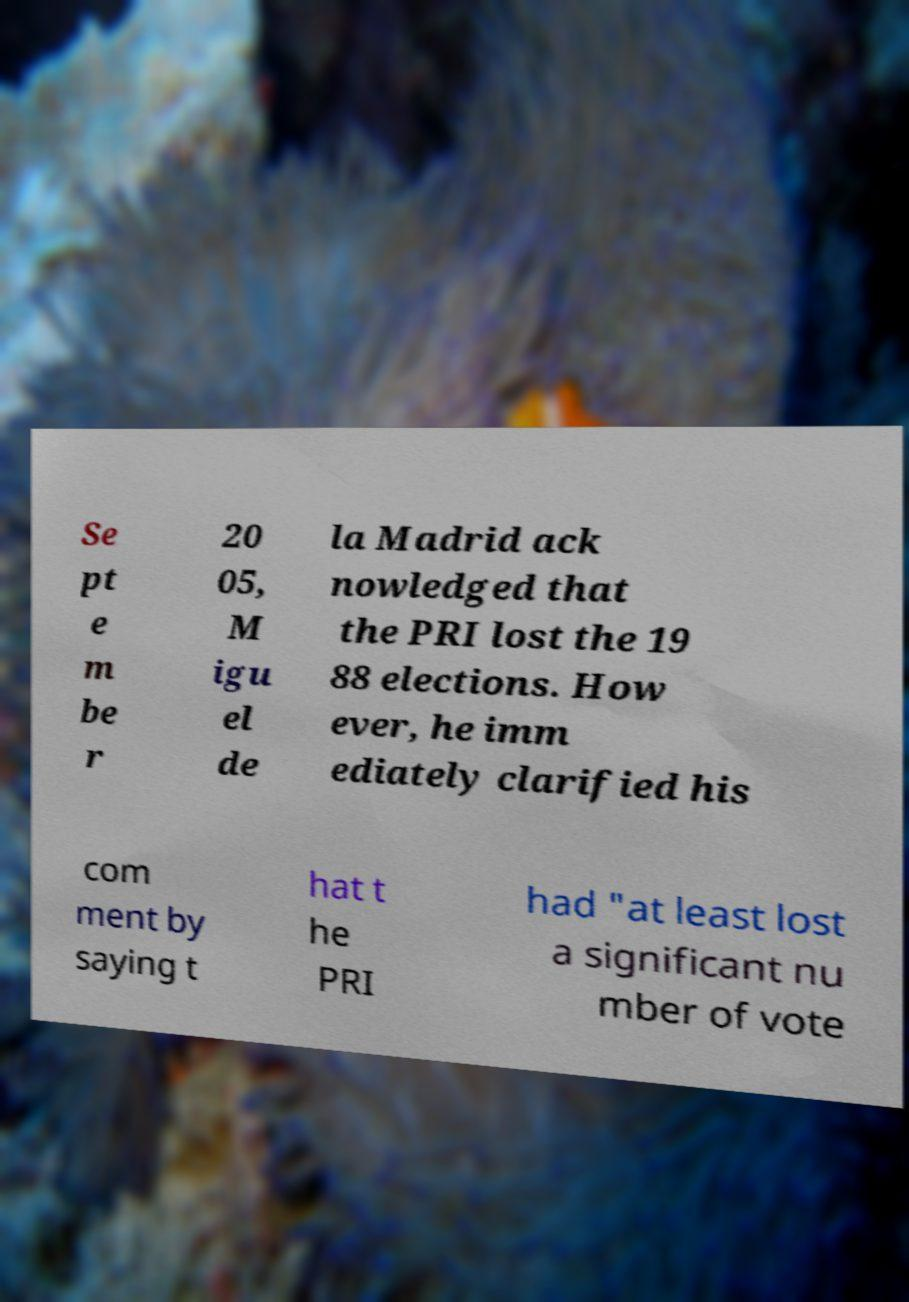Please identify and transcribe the text found in this image. Se pt e m be r 20 05, M igu el de la Madrid ack nowledged that the PRI lost the 19 88 elections. How ever, he imm ediately clarified his com ment by saying t hat t he PRI had "at least lost a significant nu mber of vote 